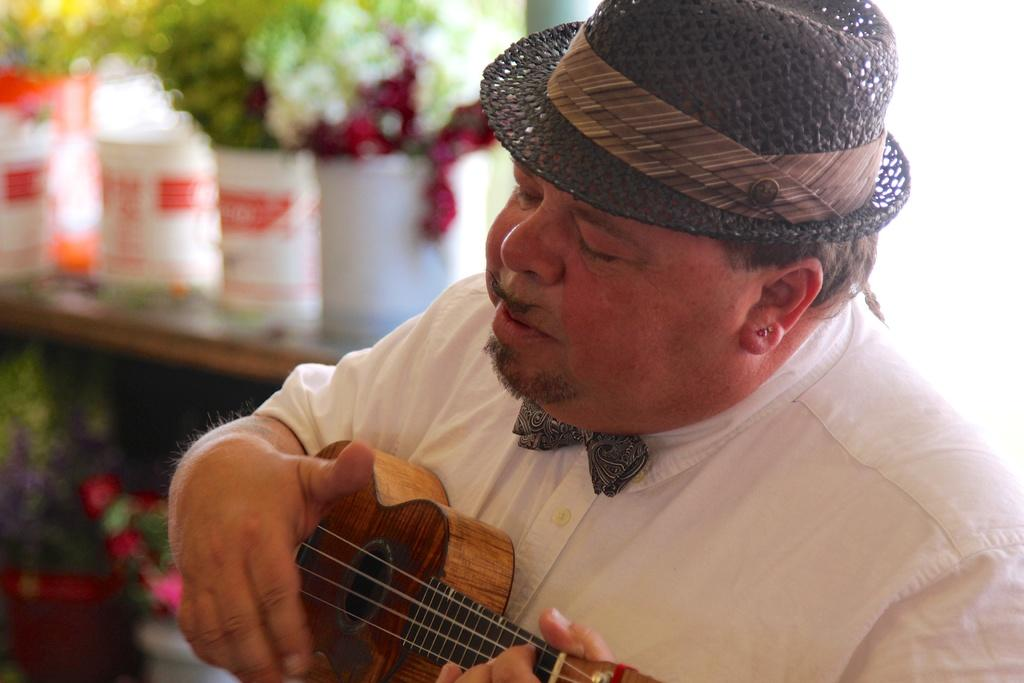What is the person in the image doing? The person is playing a guitar. What is the person wearing on their head? The person is wearing a hat. What can be seen on the left side of the image? There are plants on the left side of the image. What is the person wearing? The person is wearing a white dress. How many goldfish are swimming in the hat of the person in the image? There are no goldfish present in the image, and the person's hat does not contain any water for fish to swim in. 